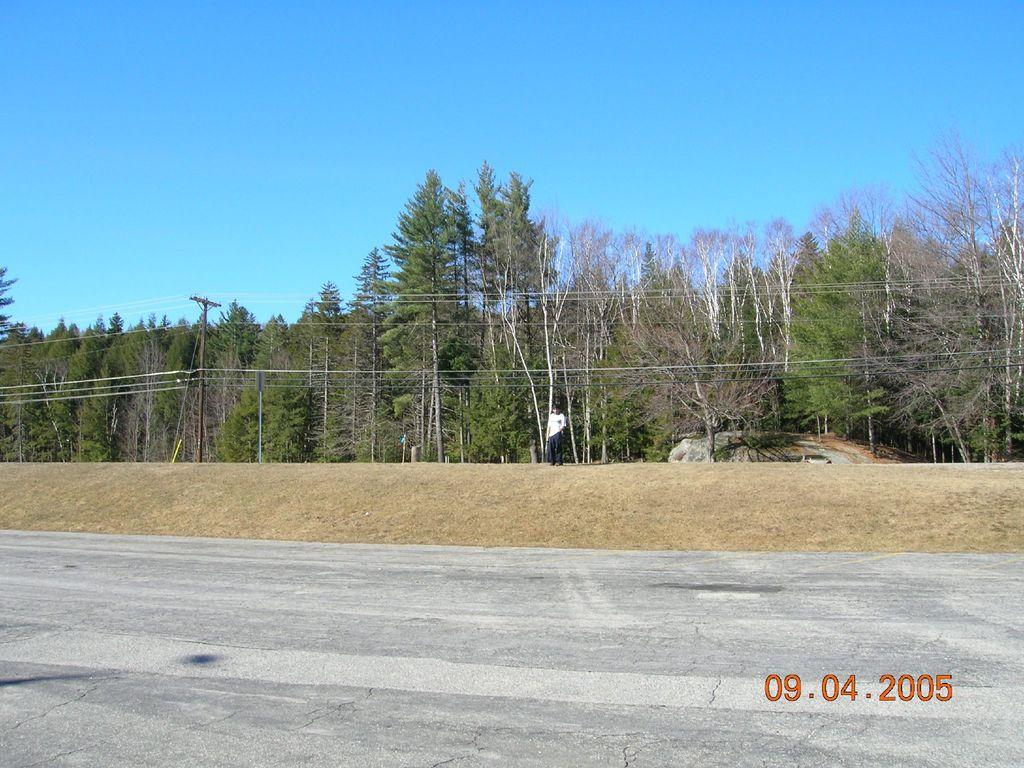Where was the image taken? The image was clicked outside. What can be seen in the middle of the image? There are trees in the middle of the image. What is located on the left side of the image? There is a pole on the left side of the image. What is visible at the top of the image? The sky is visible at the top of the image. What type of cork is used to secure the trees in the image? There is no cork present in the image, and the trees are not secured by any cork. What kind of society is depicted in the image? The image does not depict any society; it is a natural scene with trees and a pole. 